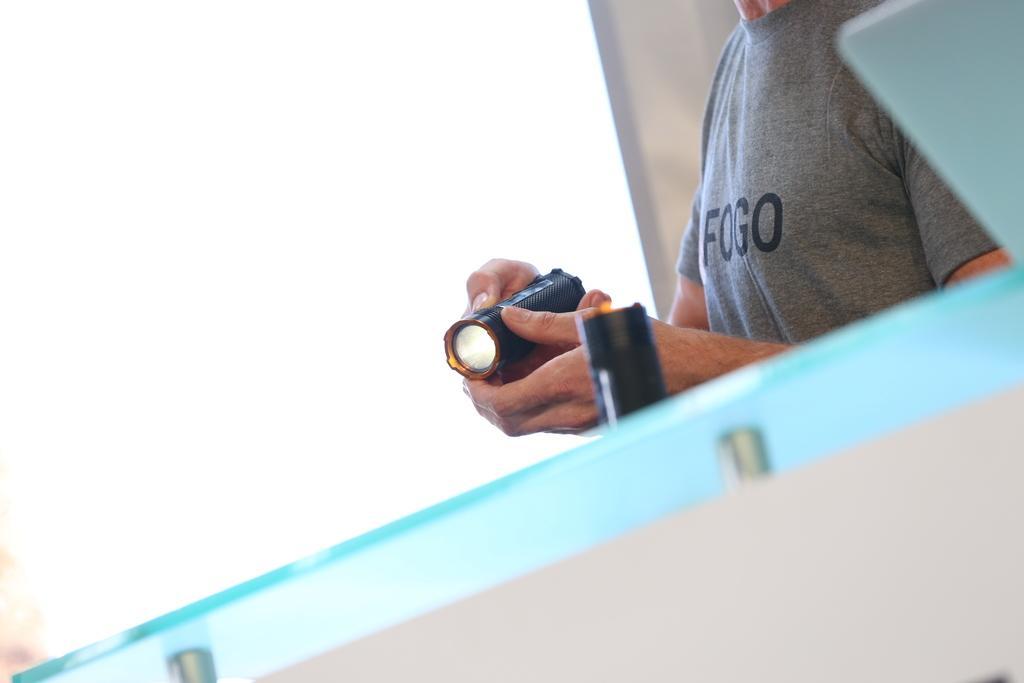Could you give a brief overview of what you see in this image? In the image in the center we can see one glass table. And we can see one person standing and holding torch light. In the background we can see wall. 